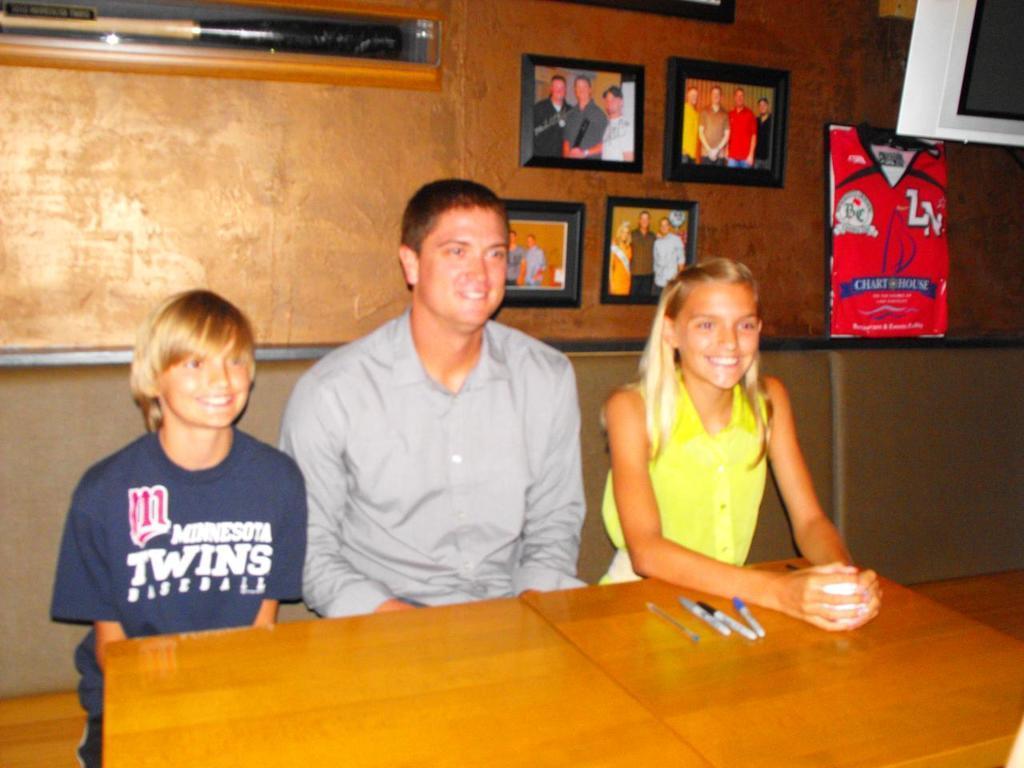Could you give a brief overview of what you see in this image? This is a picture taken in a room, there are three people sitting on a bench in front of the people there is a table on the table there are pens and cup. Background of the people is a wall on the wall there are the photos frames and a banner. 